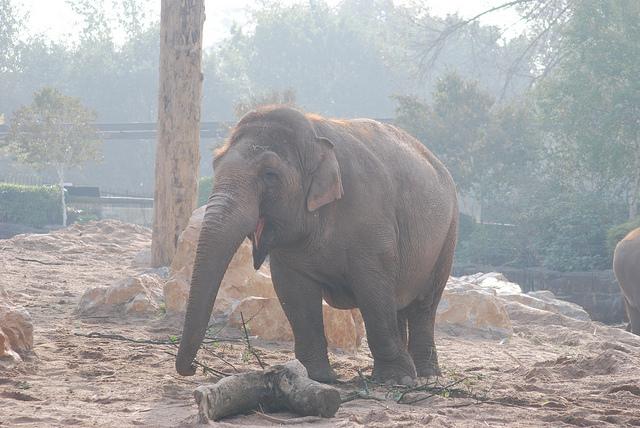How heavy is the wood?
Give a very brief answer. Very. Is the elephant walking?
Be succinct. Yes. What color is the ground?
Answer briefly. Brown. Are there any people in this image?
Concise answer only. No. Is the elephant in captivity?
Concise answer only. Yes. 